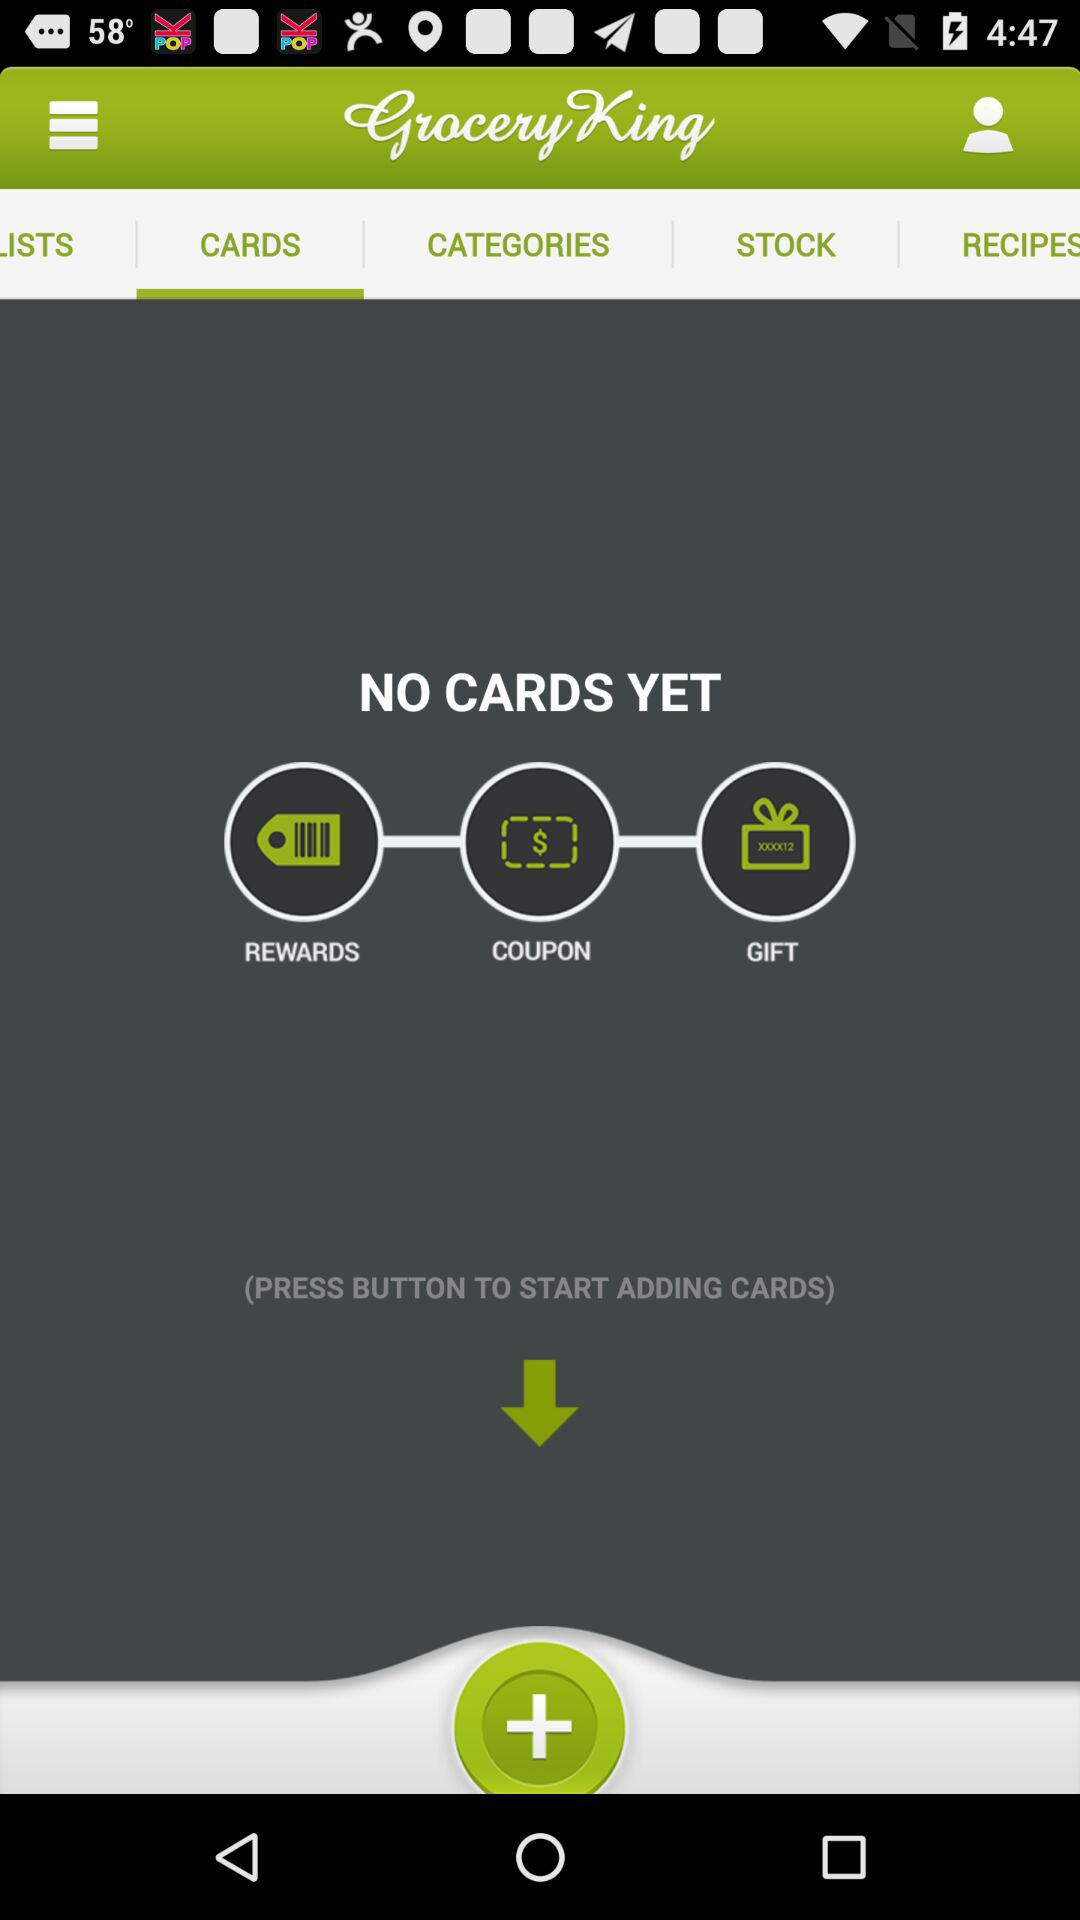What is the name of the application? The name of the application is "Grocery King". 